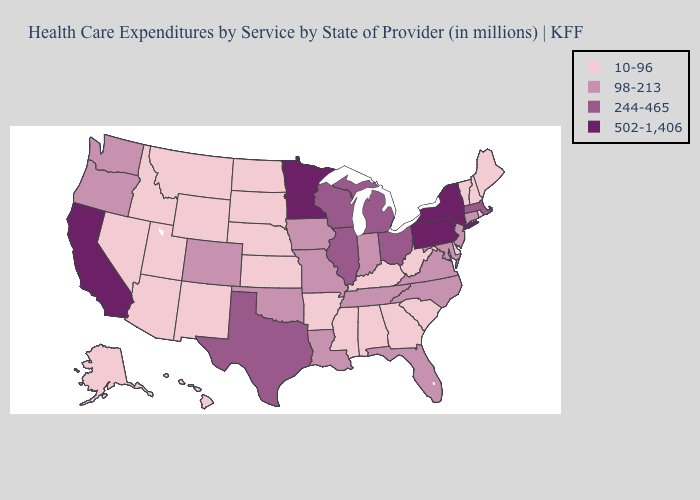What is the highest value in the South ?
Be succinct. 244-465. Among the states that border Ohio , which have the lowest value?
Give a very brief answer. Kentucky, West Virginia. Name the states that have a value in the range 502-1,406?
Answer briefly. California, Minnesota, New York, Pennsylvania. Name the states that have a value in the range 10-96?
Concise answer only. Alabama, Alaska, Arizona, Arkansas, Delaware, Georgia, Hawaii, Idaho, Kansas, Kentucky, Maine, Mississippi, Montana, Nebraska, Nevada, New Hampshire, New Mexico, North Dakota, Rhode Island, South Carolina, South Dakota, Utah, Vermont, West Virginia, Wyoming. What is the value of Oregon?
Quick response, please. 98-213. Name the states that have a value in the range 98-213?
Short answer required. Colorado, Connecticut, Florida, Indiana, Iowa, Louisiana, Maryland, Missouri, New Jersey, North Carolina, Oklahoma, Oregon, Tennessee, Virginia, Washington. What is the lowest value in the MidWest?
Keep it brief. 10-96. What is the highest value in the USA?
Keep it brief. 502-1,406. How many symbols are there in the legend?
Answer briefly. 4. What is the value of Wyoming?
Concise answer only. 10-96. What is the highest value in the MidWest ?
Give a very brief answer. 502-1,406. Name the states that have a value in the range 502-1,406?
Answer briefly. California, Minnesota, New York, Pennsylvania. What is the highest value in the USA?
Quick response, please. 502-1,406. Name the states that have a value in the range 98-213?
Write a very short answer. Colorado, Connecticut, Florida, Indiana, Iowa, Louisiana, Maryland, Missouri, New Jersey, North Carolina, Oklahoma, Oregon, Tennessee, Virginia, Washington. Among the states that border Utah , which have the lowest value?
Short answer required. Arizona, Idaho, Nevada, New Mexico, Wyoming. 